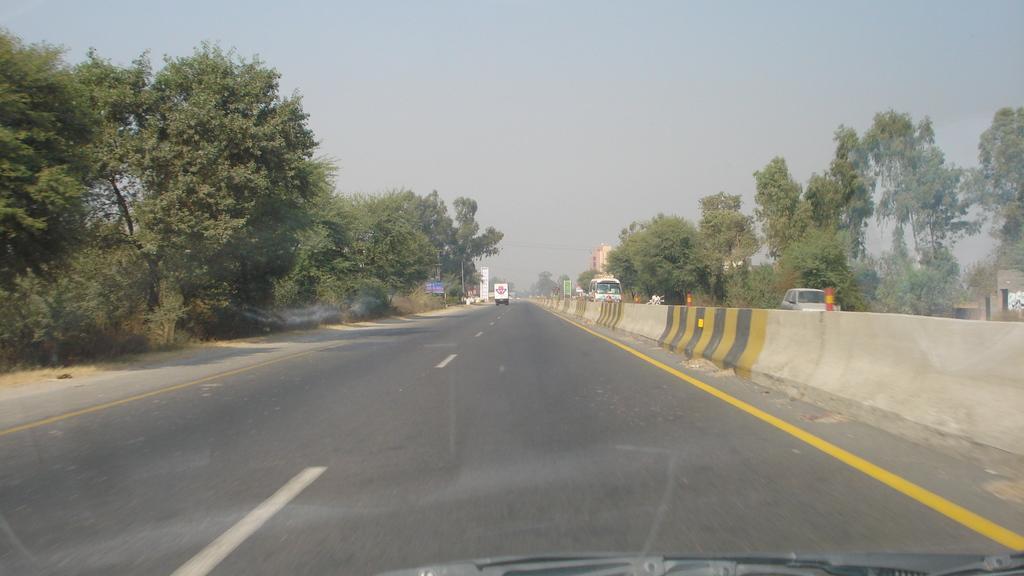Describe this image in one or two sentences. As we can see in the image there is a sky, trees, road, building and on road there is a van, bus, car and traffic cones. 